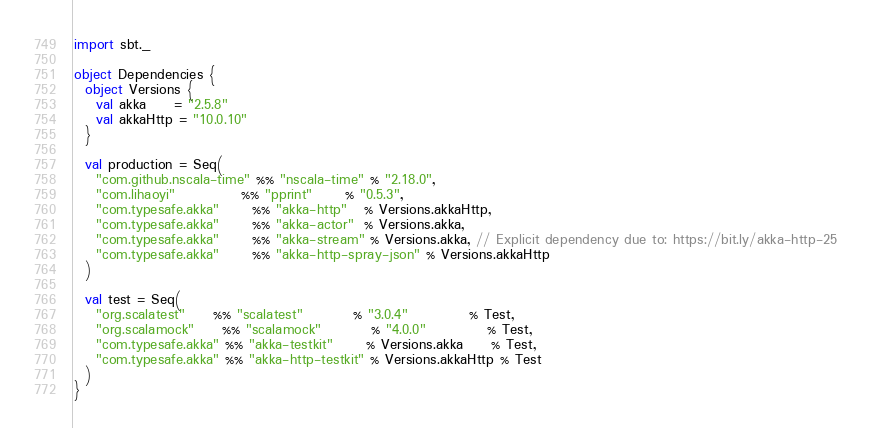<code> <loc_0><loc_0><loc_500><loc_500><_Scala_>import sbt._

object Dependencies {
  object Versions {
    val akka     = "2.5.8"
    val akkaHttp = "10.0.10"
  }

  val production = Seq(
    "com.github.nscala-time" %% "nscala-time" % "2.18.0",
    "com.lihaoyi"            %% "pprint"      % "0.5.3",
    "com.typesafe.akka"      %% "akka-http"   % Versions.akkaHttp,
    "com.typesafe.akka"      %% "akka-actor"  % Versions.akka,
    "com.typesafe.akka"      %% "akka-stream" % Versions.akka, // Explicit dependency due to: https://bit.ly/akka-http-25
    "com.typesafe.akka"      %% "akka-http-spray-json" % Versions.akkaHttp
  )

  val test = Seq(
    "org.scalatest"     %% "scalatest"         % "3.0.4"           % Test,
    "org.scalamock"     %% "scalamock"         % "4.0.0"           % Test,
    "com.typesafe.akka" %% "akka-testkit"      % Versions.akka     % Test,
    "com.typesafe.akka" %% "akka-http-testkit" % Versions.akkaHttp % Test
  )
}
</code> 